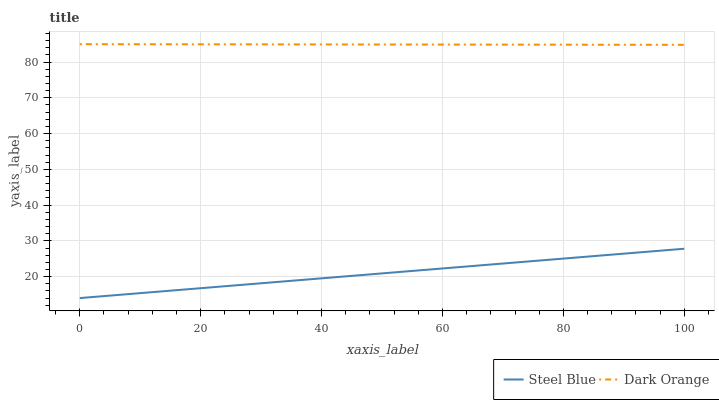Does Steel Blue have the maximum area under the curve?
Answer yes or no. No. Is Steel Blue the roughest?
Answer yes or no. No. Does Steel Blue have the highest value?
Answer yes or no. No. Is Steel Blue less than Dark Orange?
Answer yes or no. Yes. Is Dark Orange greater than Steel Blue?
Answer yes or no. Yes. Does Steel Blue intersect Dark Orange?
Answer yes or no. No. 